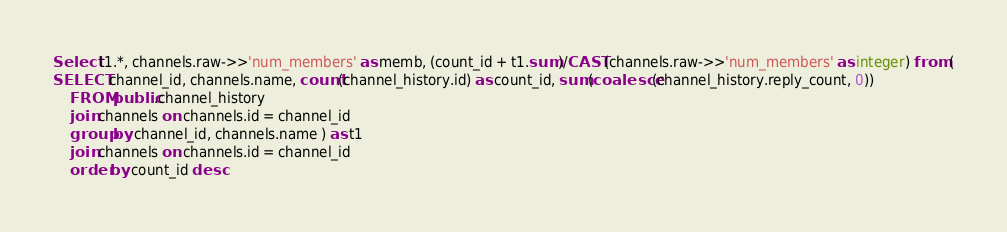Convert code to text. <code><loc_0><loc_0><loc_500><loc_500><_SQL_>Select t1.*, channels.raw->>'num_members' as memb, (count_id + t1.sum)/CAST(channels.raw->>'num_members' as integer) from (
SELECT channel_id, channels.name, count(channel_history.id) as count_id, sum(coalesce(channel_history.reply_count, 0))
	FROM public.channel_history
	join channels on channels.id = channel_id
	group by channel_id, channels.name ) as t1
	join channels on channels.id = channel_id
	order by count_id desc</code> 